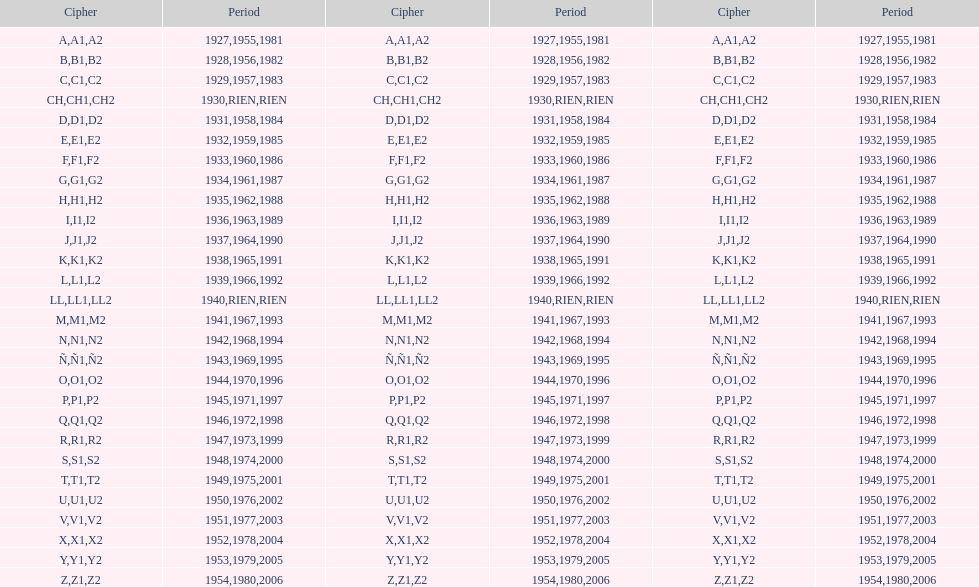Is the e code less than 1950? Yes. 